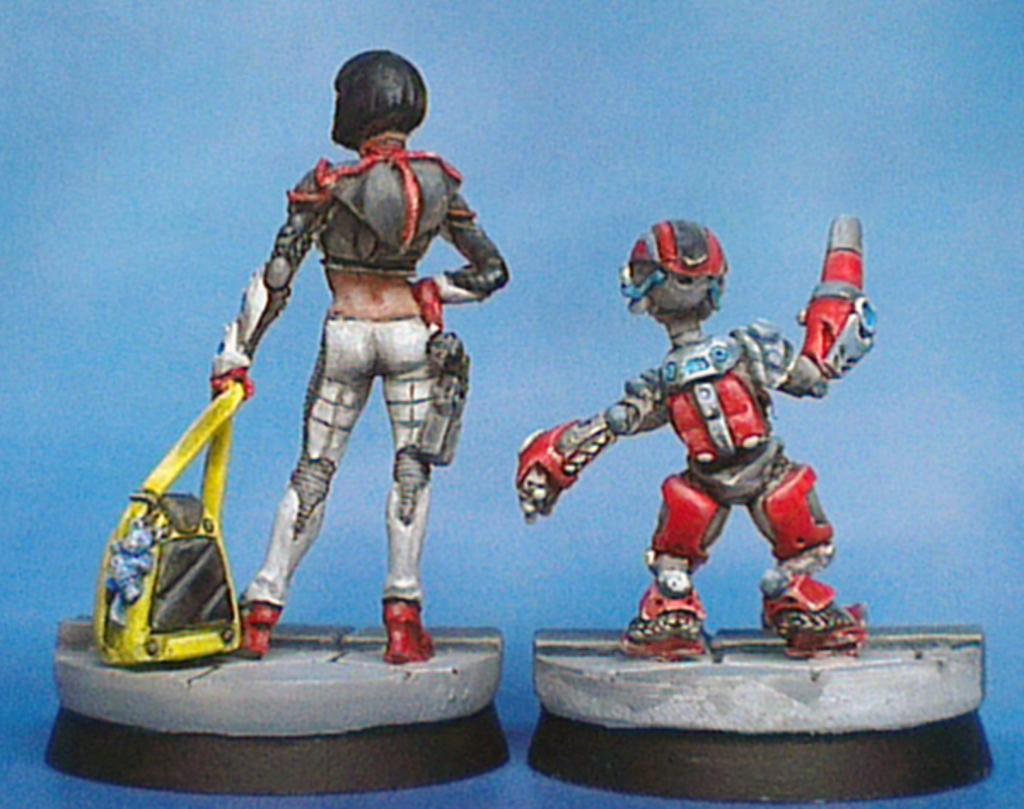What type of objects can be seen in the image? There are toys in the image. What type of grain is being harvested in the image? There is no grain or harvesting activity present in the image; it features toys. What type of trouble is the mom experiencing in the image? There is no mom or any indication of trouble in the image; it features toys. 